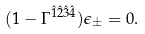Convert formula to latex. <formula><loc_0><loc_0><loc_500><loc_500>( 1 - \Gamma ^ { \hat { 1 } \hat { 2 } \hat { 3 } \hat { 4 } } ) \epsilon _ { \pm } = 0 .</formula> 